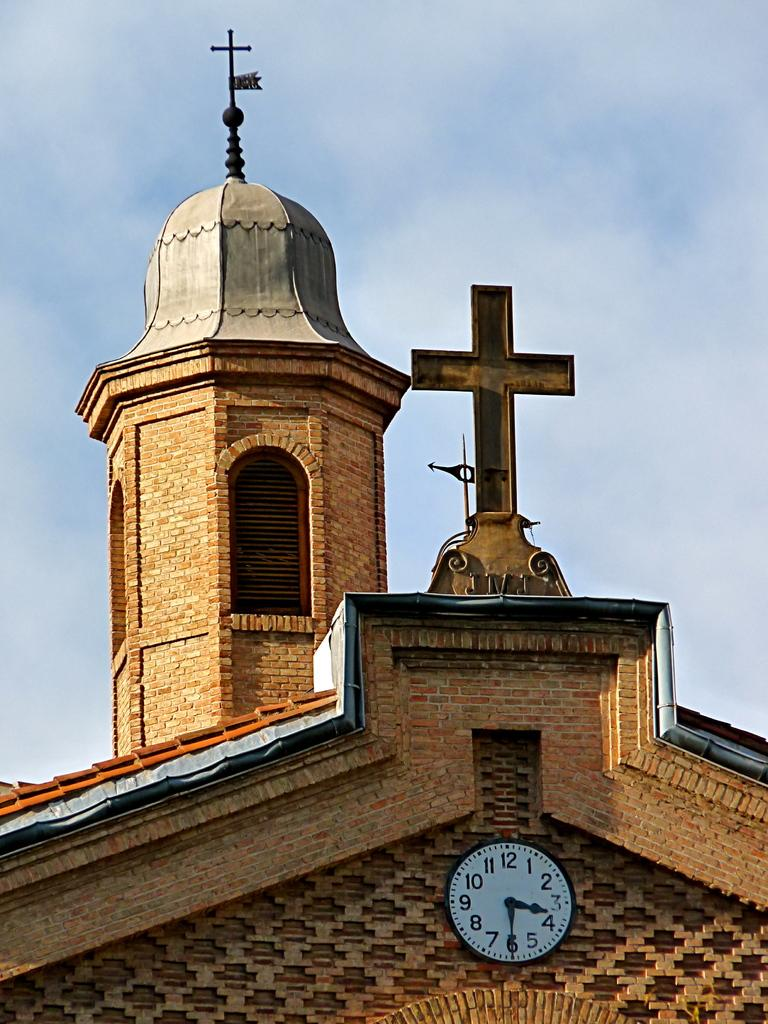<image>
Give a short and clear explanation of the subsequent image. A clock below a church's cross shows it's 3:30. 